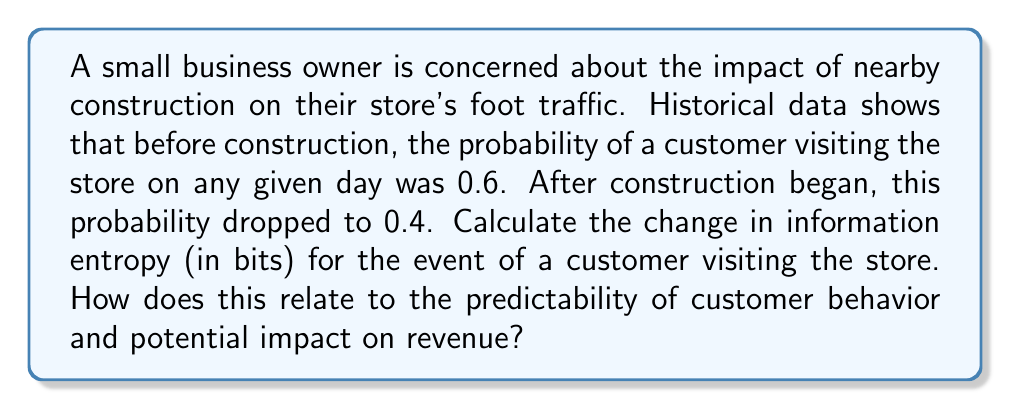Could you help me with this problem? To solve this problem, we'll use the concept of information entropy from information theory. Information entropy measures the average amount of information contained in an event and is calculated using the formula:

$$H(X) = -\sum_{i=1}^{n} p(x_i) \log_2(p(x_i))$$

Where $H(X)$ is the entropy, $p(x_i)$ is the probability of event $x_i$ occurring.

For a binary event (customer visits or doesn't visit), we can simplify this to:

$$H(X) = -p \log_2(p) - (1-p) \log_2(1-p)$$

Where $p$ is the probability of a customer visiting.

Let's calculate the entropy for both scenarios:

1. Before construction (p = 0.6):
   $$H_1 = -0.6 \log_2(0.6) - 0.4 \log_2(0.4)$$
   $$= 0.442 + 0.529 = 0.971 \text{ bits}$$

2. After construction (p = 0.4):
   $$H_2 = -0.4 \log_2(0.4) - 0.6 \log_2(0.6)$$
   $$= 0.529 + 0.442 = 0.971 \text{ bits}$$

The change in entropy is:
$$\Delta H = H_2 - H_1 = 0.971 - 0.971 = 0 \text{ bits}$$

Interestingly, the entropy remains the same in both cases. This is because the entropy function for a binary event is symmetric around p = 0.5, reaching its maximum at this point.

While the entropy hasn't changed, the decrease in the probability of customers visiting (from 0.6 to 0.4) suggests a potential decrease in revenue. The unchanged entropy indicates that the predictability of customer behavior hasn't changed, but the overall likelihood of visits has decreased.

To estimate the impact on revenue, we can calculate the relative change in expected visits:

$$\text{Relative change} = \frac{0.4 - 0.6}{0.6} \times 100\% = -33.33\%$$

This suggests a potential 33.33% decrease in foot traffic and, consequently, a similar decrease in revenue if all other factors remain constant.
Answer: The change in information entropy is 0 bits. However, the 33.33% decrease in the probability of customer visits suggests a potential 33.33% decrease in foot traffic and revenue, assuming all other factors remain constant. 